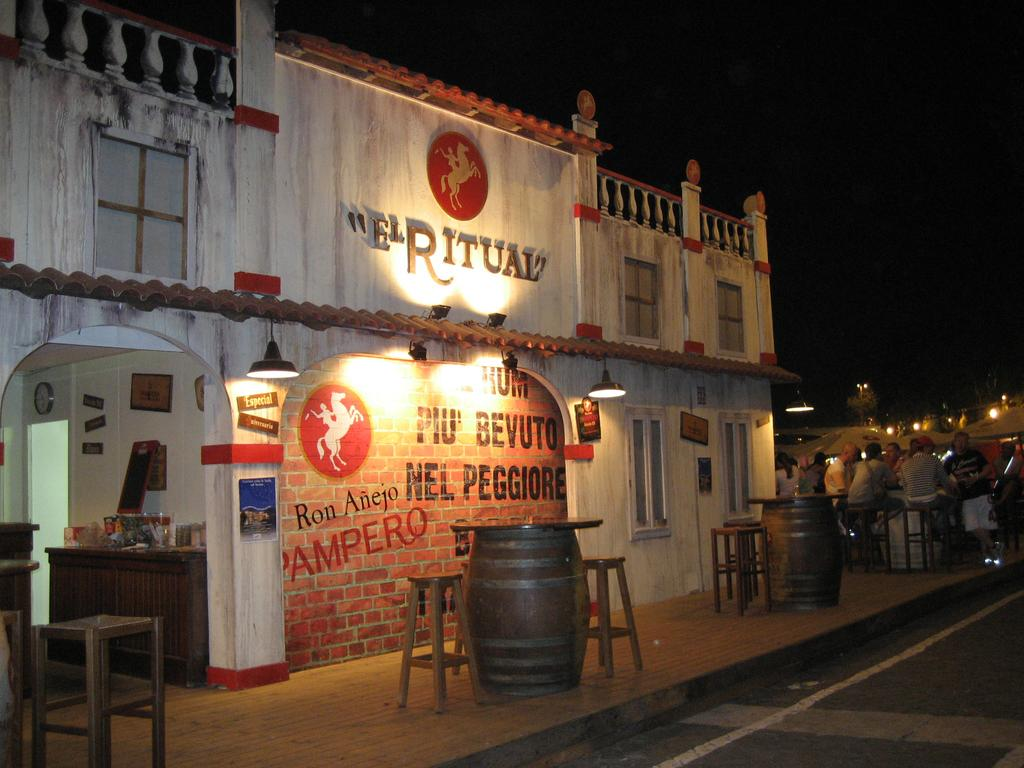Provide a one-sentence caption for the provided image. A storefront has a spotlight on "El Ritual.". 